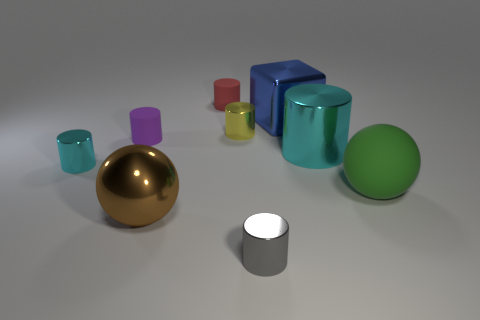Subtract all tiny purple matte cylinders. How many cylinders are left? 5 Add 1 big brown metal blocks. How many objects exist? 10 Subtract all red cylinders. How many cylinders are left? 5 Subtract all yellow cylinders. How many brown spheres are left? 1 Subtract all gray matte balls. Subtract all metallic objects. How many objects are left? 3 Add 6 green balls. How many green balls are left? 7 Add 1 tiny brown blocks. How many tiny brown blocks exist? 1 Subtract 0 blue cylinders. How many objects are left? 9 Subtract all balls. How many objects are left? 7 Subtract 1 balls. How many balls are left? 1 